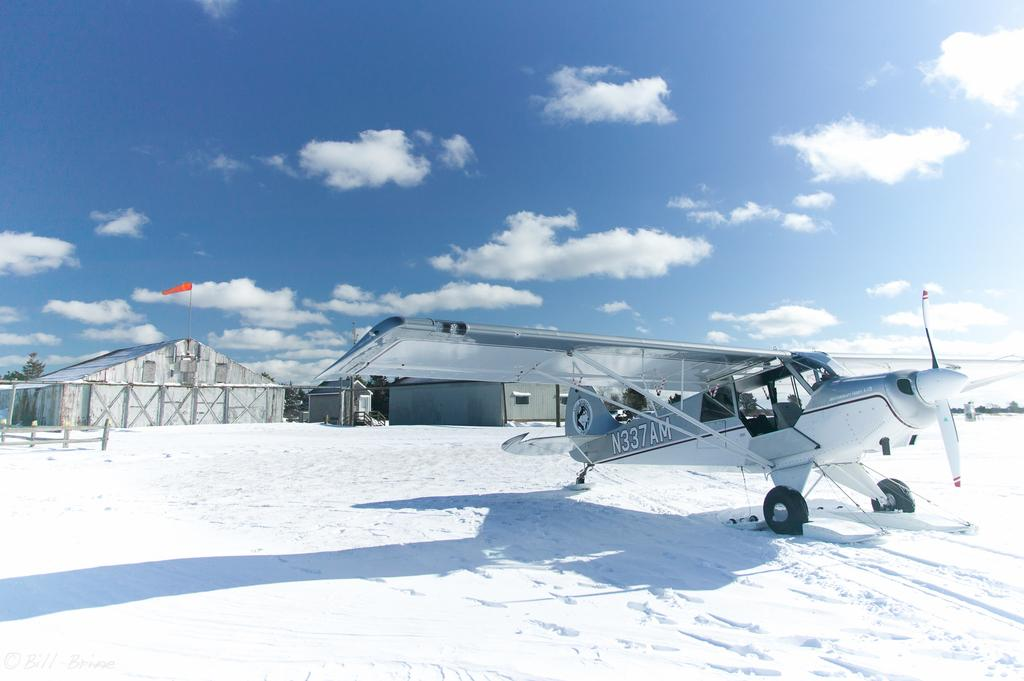Provide a one-sentence caption for the provided image. A plane with call number N337AM sits on a snowy field in front of some buildings. 